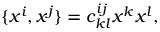<formula> <loc_0><loc_0><loc_500><loc_500>\{ x ^ { i } , x ^ { j } \} = c _ { k l } ^ { i j } x ^ { k } x ^ { l } ,</formula> 